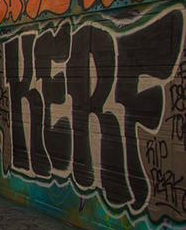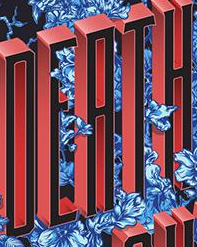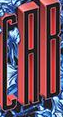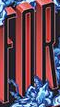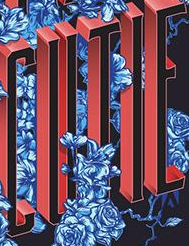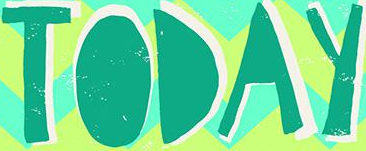Transcribe the words shown in these images in order, separated by a semicolon. KERF; DEATH; CAB; FOR; CUTIE; TODAY 